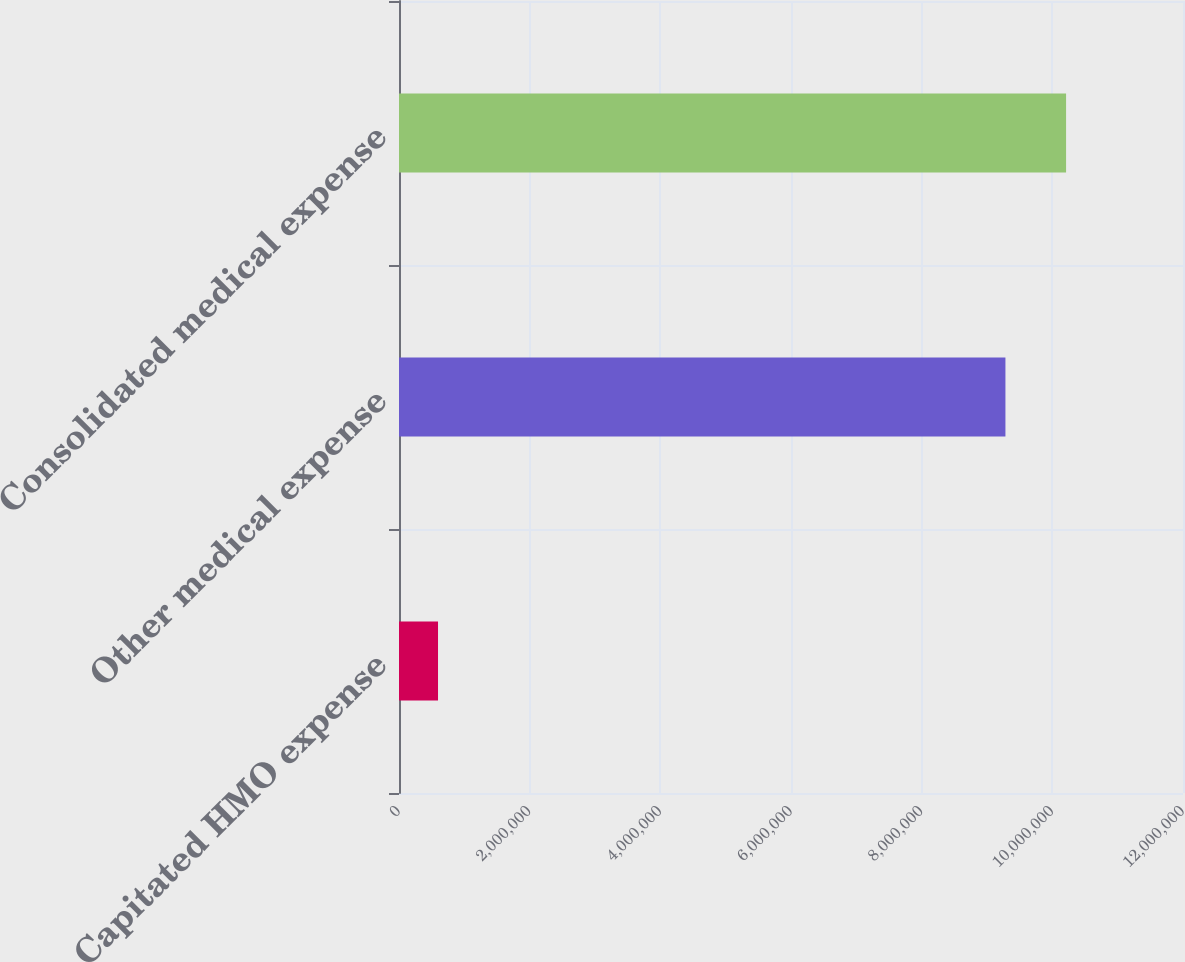Convert chart. <chart><loc_0><loc_0><loc_500><loc_500><bar_chart><fcel>Capitated HMO expense<fcel>Other medical expense<fcel>Consolidated medical expense<nl><fcel>597244<fcel>9.28218e+06<fcel>1.02104e+07<nl></chart> 